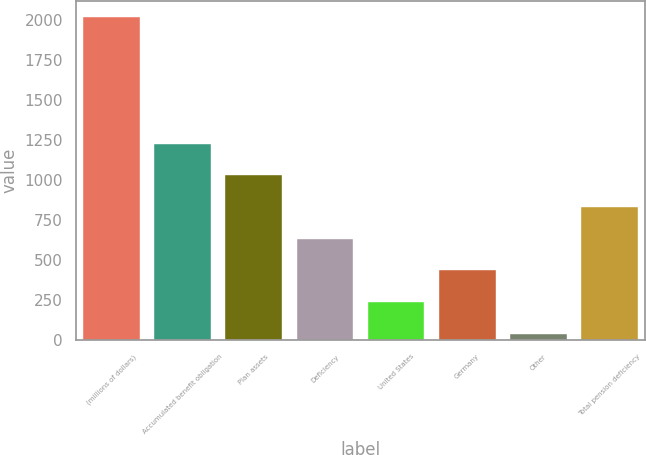Convert chart to OTSL. <chart><loc_0><loc_0><loc_500><loc_500><bar_chart><fcel>(millions of dollars)<fcel>Accumulated benefit obligation<fcel>Plan assets<fcel>Deficiency<fcel>United States<fcel>Germany<fcel>Other<fcel>Total pension deficiency<nl><fcel>2016<fcel>1225.68<fcel>1028.1<fcel>632.94<fcel>237.78<fcel>435.36<fcel>40.2<fcel>830.52<nl></chart> 